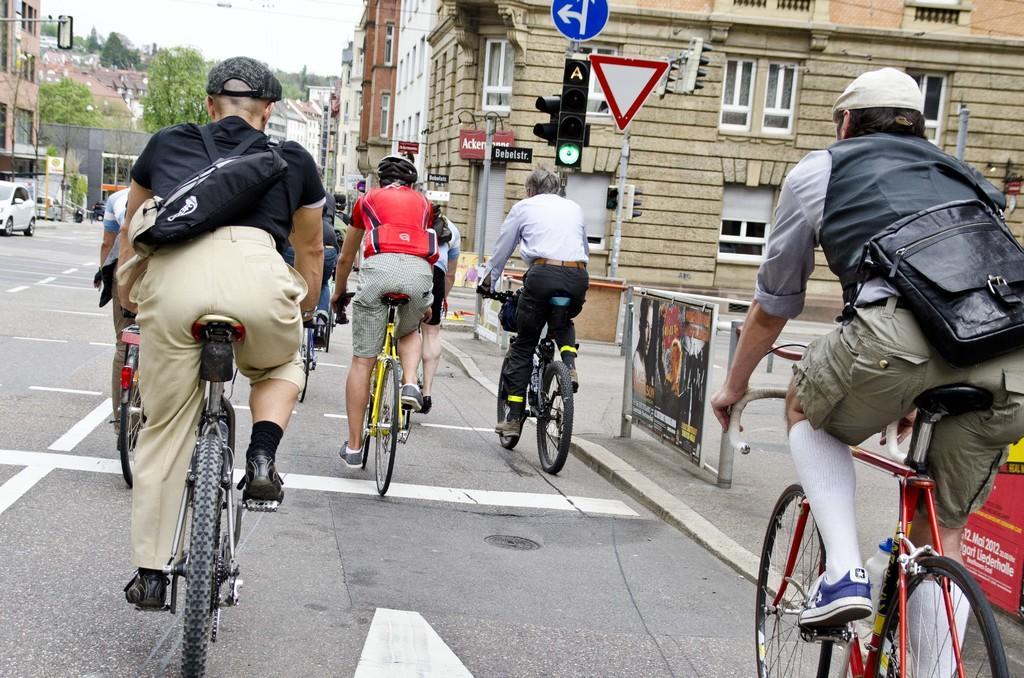Please provide a concise description of this image. In the middle of the image few people are sitting on bicycles and riding. Bottom right side of the image there are few banners. Top right side of the image there is a signal pole and sign board. Behind the pole there are few buildings. Top left side of the image there are few vehicles and trees. At the top of the image there is a sky. 